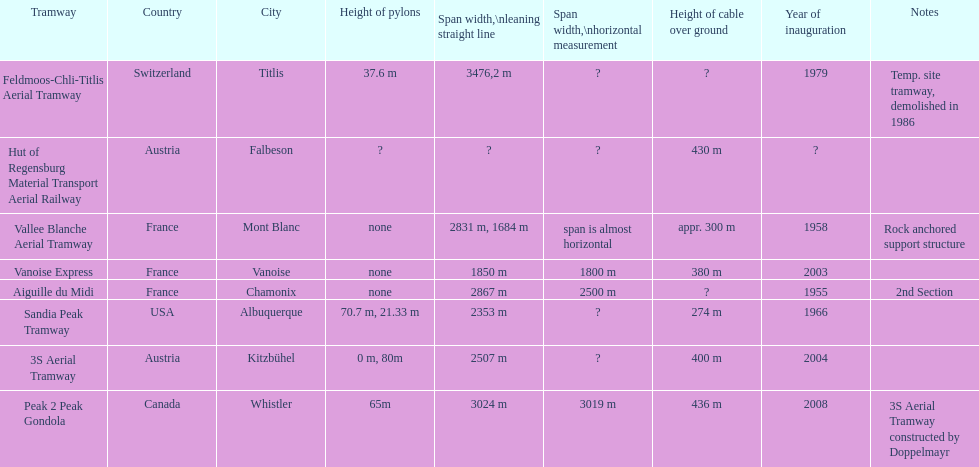How much greater is the height of cable over ground measurement for the peak 2 peak gondola when compared with that of the vanoise express? 56 m. 